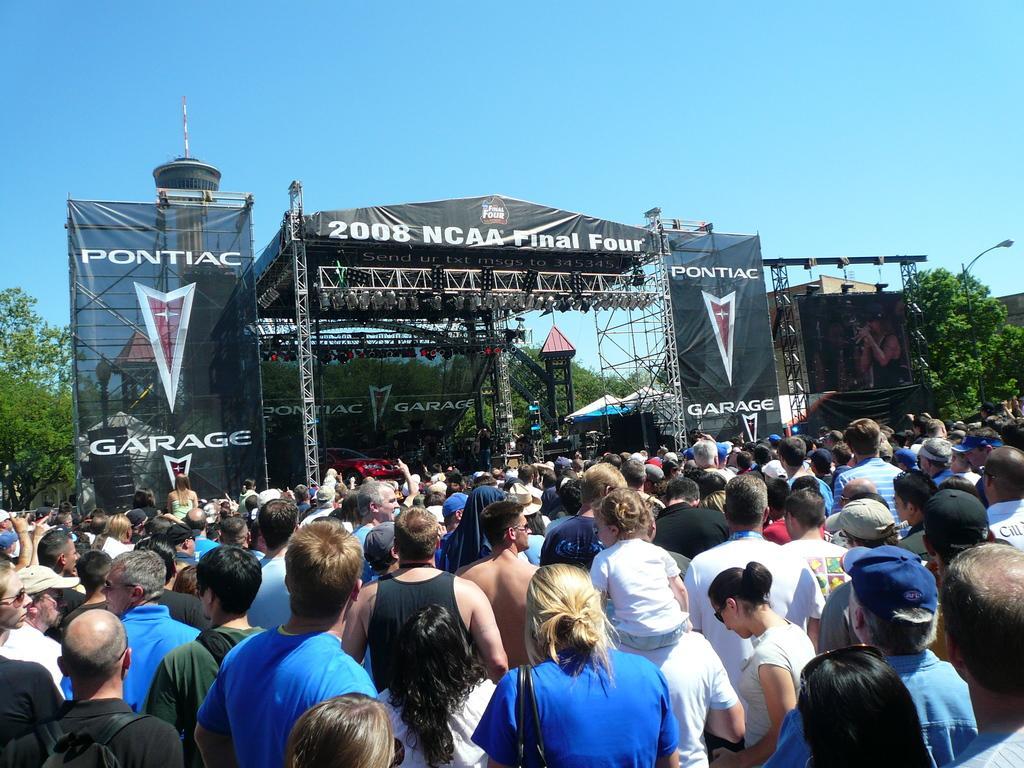How would you summarize this image in a sentence or two? In this image I can see the group of people and they are wearing different color dresses. I can see few trees, light pole, banners, stage, lights and the sky. 